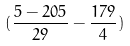Convert formula to latex. <formula><loc_0><loc_0><loc_500><loc_500>( \frac { 5 - 2 0 5 } { 2 9 } - \frac { 1 7 9 } { 4 } )</formula> 